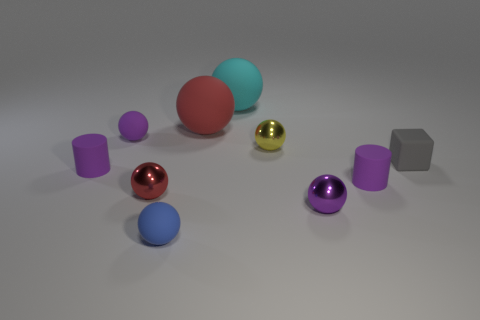Subtract all small shiny balls. How many balls are left? 4 Subtract all cyan spheres. How many spheres are left? 6 Subtract all gray balls. Subtract all cyan cylinders. How many balls are left? 7 Subtract all spheres. How many objects are left? 3 Subtract 0 brown blocks. How many objects are left? 10 Subtract all small blue balls. Subtract all red shiny objects. How many objects are left? 8 Add 5 small red things. How many small red things are left? 6 Add 6 tiny shiny balls. How many tiny shiny balls exist? 9 